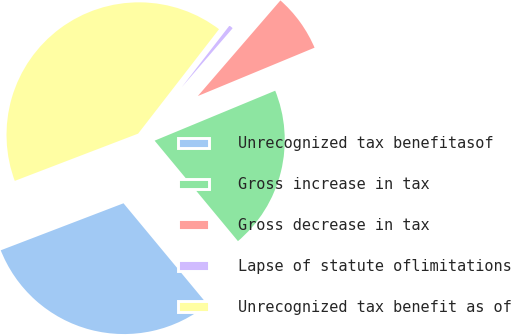Convert chart. <chart><loc_0><loc_0><loc_500><loc_500><pie_chart><fcel>Unrecognized tax benefitasof<fcel>Gross increase in tax<fcel>Gross decrease in tax<fcel>Lapse of statute oflimitations<fcel>Unrecognized tax benefit as of<nl><fcel>30.2%<fcel>20.23%<fcel>7.41%<fcel>0.85%<fcel>41.31%<nl></chart> 